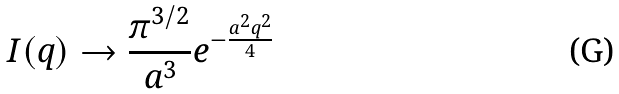Convert formula to latex. <formula><loc_0><loc_0><loc_500><loc_500>I ( q ) \rightarrow \frac { \pi ^ { 3 / 2 } } { a ^ { 3 } } e ^ { - \frac { a ^ { 2 } q ^ { 2 } } { 4 } }</formula> 